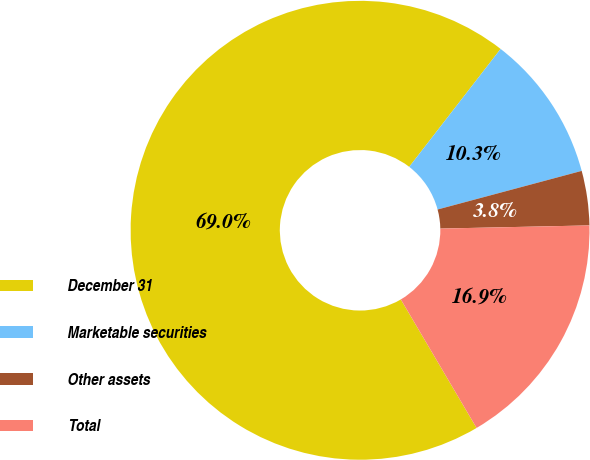Convert chart. <chart><loc_0><loc_0><loc_500><loc_500><pie_chart><fcel>December 31<fcel>Marketable securities<fcel>Other assets<fcel>Total<nl><fcel>68.97%<fcel>10.34%<fcel>3.83%<fcel>16.86%<nl></chart> 